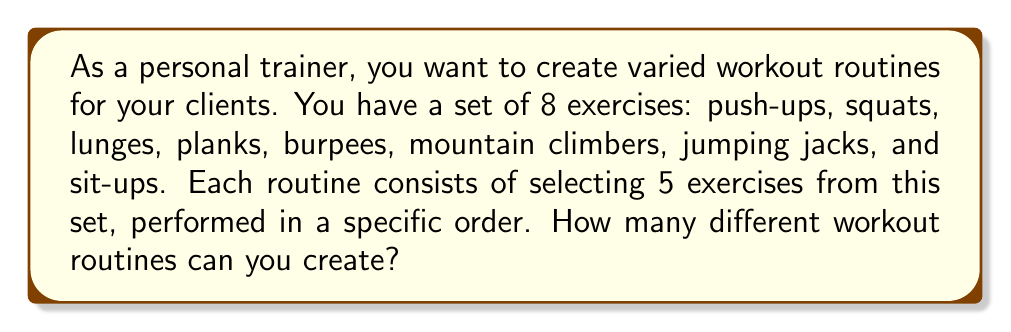What is the answer to this math problem? Let's approach this step-by-step:

1) This is a permutation problem. We are selecting 5 exercises out of 8, and the order matters (as the exercises are performed in a specific sequence).

2) The formula for permutations is:

   $$P(n,r) = \frac{n!}{(n-r)!}$$

   where $n$ is the total number of items to choose from, and $r$ is the number of items being chosen.

3) In this case, $n = 8$ (total exercises) and $r = 5$ (exercises in each routine).

4) Plugging these values into the formula:

   $$P(8,5) = \frac{8!}{(8-5)!} = \frac{8!}{3!}$$

5) Expanding this:
   
   $$\frac{8 * 7 * 6 * 5 * 4 * 3!}{3!}$$

6) The $3!$ cancels out in the numerator and denominator:

   $$8 * 7 * 6 * 5 * 4 = 6720$$

Therefore, you can create 6,720 different workout routines.
Answer: 6,720 